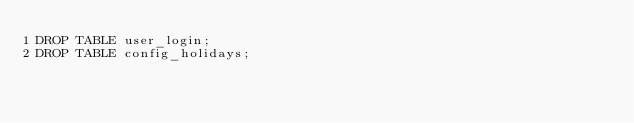<code> <loc_0><loc_0><loc_500><loc_500><_SQL_>DROP TABLE user_login;
DROP TABLE config_holidays;</code> 